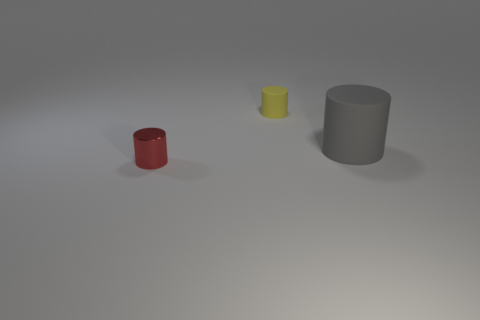Is there any other thing that is the same material as the small red object?
Make the answer very short. No. Is the shape of the red metal object the same as the rubber object left of the gray rubber cylinder?
Keep it short and to the point. Yes. What is the material of the small object that is behind the rubber cylinder to the right of the rubber object that is on the left side of the large gray rubber thing?
Ensure brevity in your answer.  Rubber. What number of gray objects are there?
Your answer should be very brief. 1. What number of red things are big rubber cylinders or tiny shiny things?
Provide a succinct answer. 1. How many small things are green cylinders or red cylinders?
Your answer should be compact. 1. What size is the other gray rubber thing that is the same shape as the tiny matte object?
Your answer should be compact. Large. Are there any other things that are the same size as the gray rubber cylinder?
Ensure brevity in your answer.  No. The thing that is right of the rubber cylinder that is behind the gray cylinder is made of what material?
Ensure brevity in your answer.  Rubber. How many metal objects are either tiny brown cylinders or small red cylinders?
Give a very brief answer. 1. 